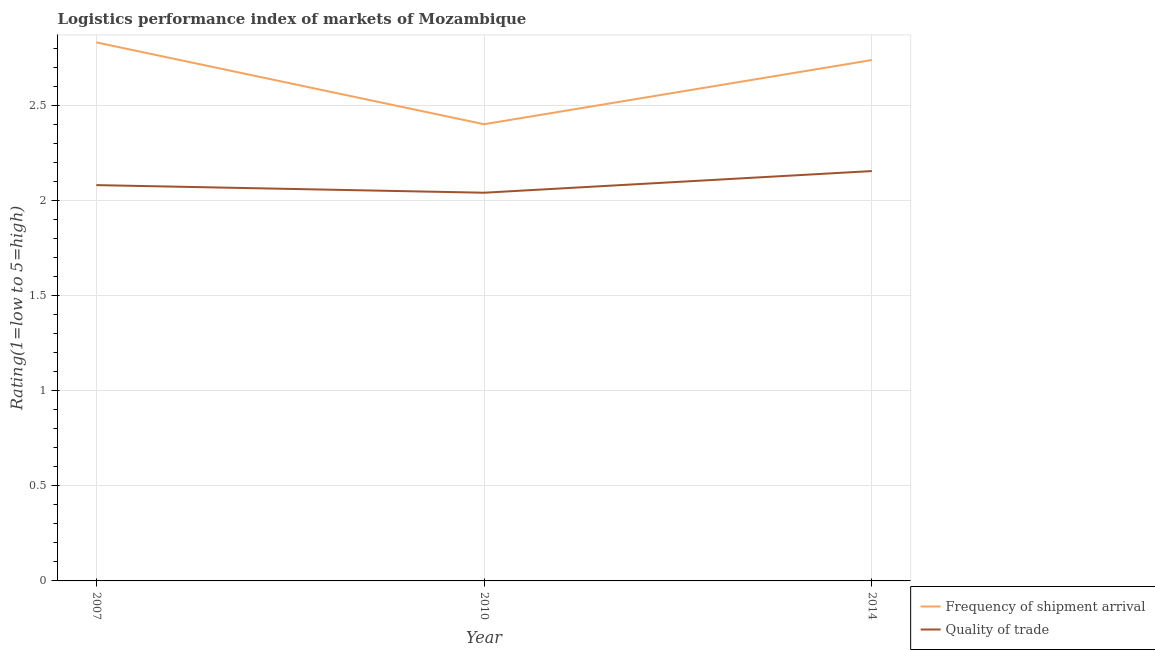How many different coloured lines are there?
Your answer should be very brief. 2. Does the line corresponding to lpi of frequency of shipment arrival intersect with the line corresponding to lpi quality of trade?
Provide a short and direct response. No. What is the lpi of frequency of shipment arrival in 2007?
Your answer should be compact. 2.83. Across all years, what is the maximum lpi quality of trade?
Provide a short and direct response. 2.15. Across all years, what is the minimum lpi quality of trade?
Keep it short and to the point. 2.04. In which year was the lpi quality of trade maximum?
Provide a short and direct response. 2014. What is the total lpi quality of trade in the graph?
Give a very brief answer. 6.27. What is the difference between the lpi of frequency of shipment arrival in 2007 and that in 2014?
Provide a succinct answer. 0.09. What is the difference between the lpi of frequency of shipment arrival in 2010 and the lpi quality of trade in 2014?
Provide a short and direct response. 0.25. What is the average lpi of frequency of shipment arrival per year?
Ensure brevity in your answer.  2.66. In the year 2014, what is the difference between the lpi quality of trade and lpi of frequency of shipment arrival?
Your answer should be compact. -0.58. What is the ratio of the lpi quality of trade in 2007 to that in 2014?
Your response must be concise. 0.97. Is the lpi quality of trade in 2007 less than that in 2010?
Ensure brevity in your answer.  No. Is the difference between the lpi quality of trade in 2007 and 2010 greater than the difference between the lpi of frequency of shipment arrival in 2007 and 2010?
Offer a very short reply. No. What is the difference between the highest and the second highest lpi of frequency of shipment arrival?
Your response must be concise. 0.09. What is the difference between the highest and the lowest lpi of frequency of shipment arrival?
Give a very brief answer. 0.43. In how many years, is the lpi of frequency of shipment arrival greater than the average lpi of frequency of shipment arrival taken over all years?
Your answer should be very brief. 2. Does the lpi of frequency of shipment arrival monotonically increase over the years?
Keep it short and to the point. No. How many years are there in the graph?
Ensure brevity in your answer.  3. Are the values on the major ticks of Y-axis written in scientific E-notation?
Your answer should be compact. No. Where does the legend appear in the graph?
Ensure brevity in your answer.  Bottom right. How many legend labels are there?
Give a very brief answer. 2. What is the title of the graph?
Your answer should be very brief. Logistics performance index of markets of Mozambique. Does "Forest" appear as one of the legend labels in the graph?
Ensure brevity in your answer.  No. What is the label or title of the X-axis?
Your answer should be compact. Year. What is the label or title of the Y-axis?
Offer a terse response. Rating(1=low to 5=high). What is the Rating(1=low to 5=high) in Frequency of shipment arrival in 2007?
Ensure brevity in your answer.  2.83. What is the Rating(1=low to 5=high) of Quality of trade in 2007?
Make the answer very short. 2.08. What is the Rating(1=low to 5=high) of Frequency of shipment arrival in 2010?
Give a very brief answer. 2.4. What is the Rating(1=low to 5=high) of Quality of trade in 2010?
Offer a very short reply. 2.04. What is the Rating(1=low to 5=high) of Frequency of shipment arrival in 2014?
Offer a very short reply. 2.74. What is the Rating(1=low to 5=high) of Quality of trade in 2014?
Provide a succinct answer. 2.15. Across all years, what is the maximum Rating(1=low to 5=high) in Frequency of shipment arrival?
Provide a succinct answer. 2.83. Across all years, what is the maximum Rating(1=low to 5=high) of Quality of trade?
Offer a very short reply. 2.15. Across all years, what is the minimum Rating(1=low to 5=high) of Quality of trade?
Make the answer very short. 2.04. What is the total Rating(1=low to 5=high) of Frequency of shipment arrival in the graph?
Your answer should be compact. 7.97. What is the total Rating(1=low to 5=high) in Quality of trade in the graph?
Provide a succinct answer. 6.27. What is the difference between the Rating(1=low to 5=high) in Frequency of shipment arrival in 2007 and that in 2010?
Your response must be concise. 0.43. What is the difference between the Rating(1=low to 5=high) of Quality of trade in 2007 and that in 2010?
Provide a short and direct response. 0.04. What is the difference between the Rating(1=low to 5=high) of Frequency of shipment arrival in 2007 and that in 2014?
Your response must be concise. 0.09. What is the difference between the Rating(1=low to 5=high) of Quality of trade in 2007 and that in 2014?
Your answer should be very brief. -0.07. What is the difference between the Rating(1=low to 5=high) in Frequency of shipment arrival in 2010 and that in 2014?
Your answer should be very brief. -0.34. What is the difference between the Rating(1=low to 5=high) of Quality of trade in 2010 and that in 2014?
Make the answer very short. -0.11. What is the difference between the Rating(1=low to 5=high) of Frequency of shipment arrival in 2007 and the Rating(1=low to 5=high) of Quality of trade in 2010?
Provide a succinct answer. 0.79. What is the difference between the Rating(1=low to 5=high) in Frequency of shipment arrival in 2007 and the Rating(1=low to 5=high) in Quality of trade in 2014?
Make the answer very short. 0.68. What is the difference between the Rating(1=low to 5=high) in Frequency of shipment arrival in 2010 and the Rating(1=low to 5=high) in Quality of trade in 2014?
Offer a very short reply. 0.25. What is the average Rating(1=low to 5=high) of Frequency of shipment arrival per year?
Your response must be concise. 2.66. What is the average Rating(1=low to 5=high) of Quality of trade per year?
Offer a very short reply. 2.09. In the year 2010, what is the difference between the Rating(1=low to 5=high) in Frequency of shipment arrival and Rating(1=low to 5=high) in Quality of trade?
Offer a terse response. 0.36. In the year 2014, what is the difference between the Rating(1=low to 5=high) in Frequency of shipment arrival and Rating(1=low to 5=high) in Quality of trade?
Your answer should be very brief. 0.58. What is the ratio of the Rating(1=low to 5=high) of Frequency of shipment arrival in 2007 to that in 2010?
Provide a short and direct response. 1.18. What is the ratio of the Rating(1=low to 5=high) of Quality of trade in 2007 to that in 2010?
Give a very brief answer. 1.02. What is the ratio of the Rating(1=low to 5=high) in Frequency of shipment arrival in 2007 to that in 2014?
Give a very brief answer. 1.03. What is the ratio of the Rating(1=low to 5=high) in Quality of trade in 2007 to that in 2014?
Make the answer very short. 0.97. What is the ratio of the Rating(1=low to 5=high) of Frequency of shipment arrival in 2010 to that in 2014?
Offer a very short reply. 0.88. What is the ratio of the Rating(1=low to 5=high) in Quality of trade in 2010 to that in 2014?
Your response must be concise. 0.95. What is the difference between the highest and the second highest Rating(1=low to 5=high) in Frequency of shipment arrival?
Make the answer very short. 0.09. What is the difference between the highest and the second highest Rating(1=low to 5=high) in Quality of trade?
Your response must be concise. 0.07. What is the difference between the highest and the lowest Rating(1=low to 5=high) of Frequency of shipment arrival?
Offer a terse response. 0.43. What is the difference between the highest and the lowest Rating(1=low to 5=high) in Quality of trade?
Give a very brief answer. 0.11. 